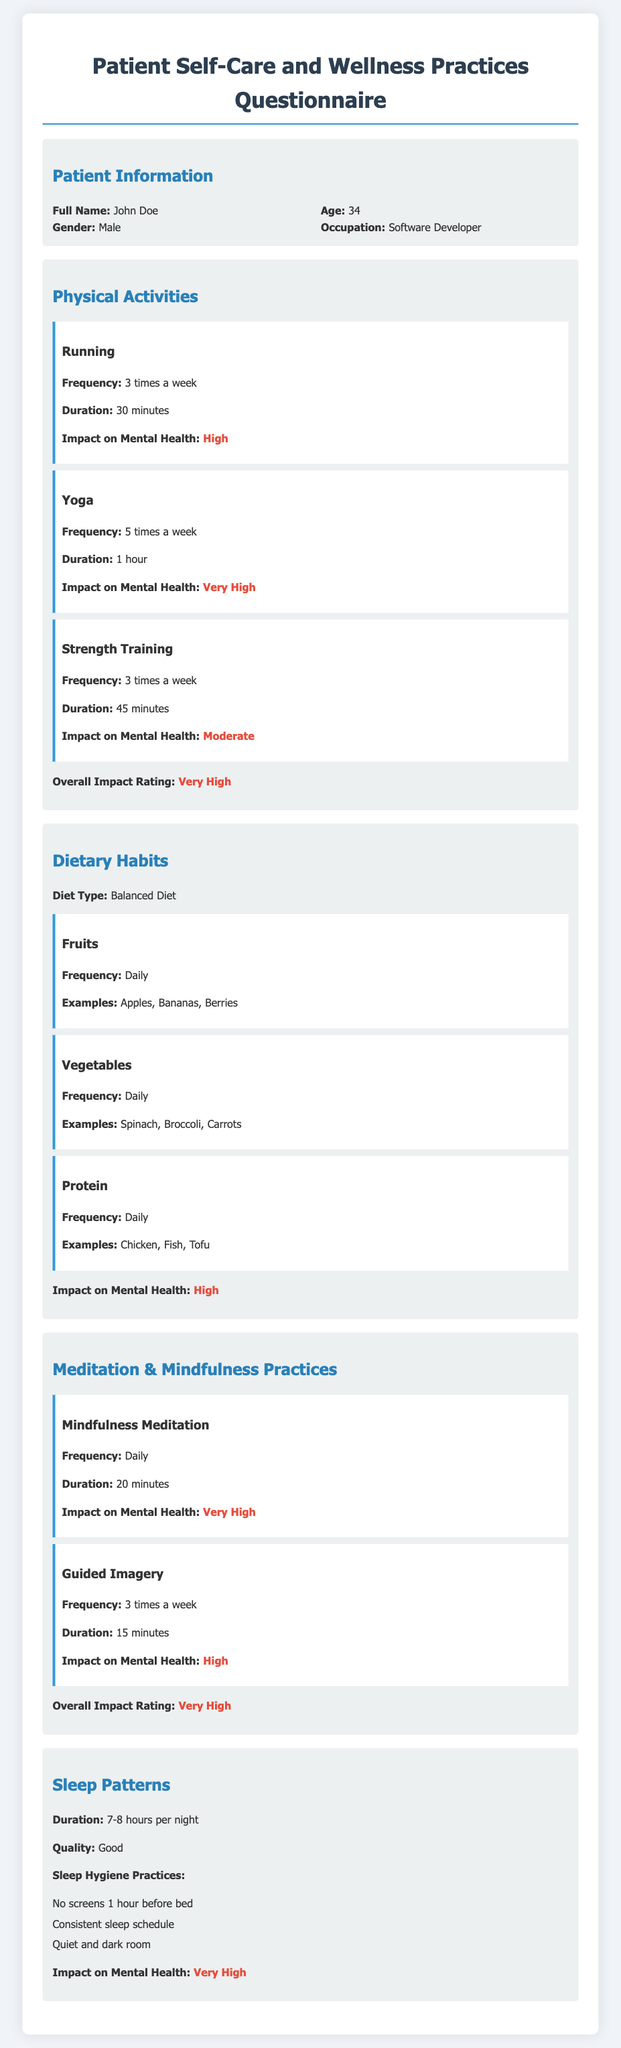What is the full name of the patient? The patient's full name is provided in the Patient Information section of the document.
Answer: John Doe How old is the patient? The patient's age is mentioned in the Patient Information section of the document.
Answer: 34 What is the patient's occupation? The patient's occupation is stated in the Patient Information section of the document.
Answer: Software Developer How many times a week does the patient run? The frequency of the patient's running activity is detailed in the Physical Activities section.
Answer: 3 times a week What is the impact of yoga on the patient's mental health? The impact of yoga on the patient's mental health is explicitly stated in the Physical Activities section of the document.
Answer: Very High What type of diet does the patient follow? The type of diet the patient follows is indicated in the Dietary Habits section.
Answer: Balanced Diet How long does the patient practice mindfulness meditation daily? The duration of the patient's mindfulness meditation practice is mentioned in the Meditation & Mindfulness Practices section.
Answer: 20 minutes What is the patient's sleep duration per night? The patient's sleep duration is specified in the Sleep Patterns section.
Answer: 7-8 hours What sleep hygiene practice does the patient follow regarding screens? The specific sleep hygiene practice about screens is provided in the Sleep Patterns section.
Answer: No screens 1 hour before bed What is the overall impact rating of the patient's physical activities on their mental health? The overall impact rating of physical activities on mental health is stated in the Physical Activities section.
Answer: Very High 